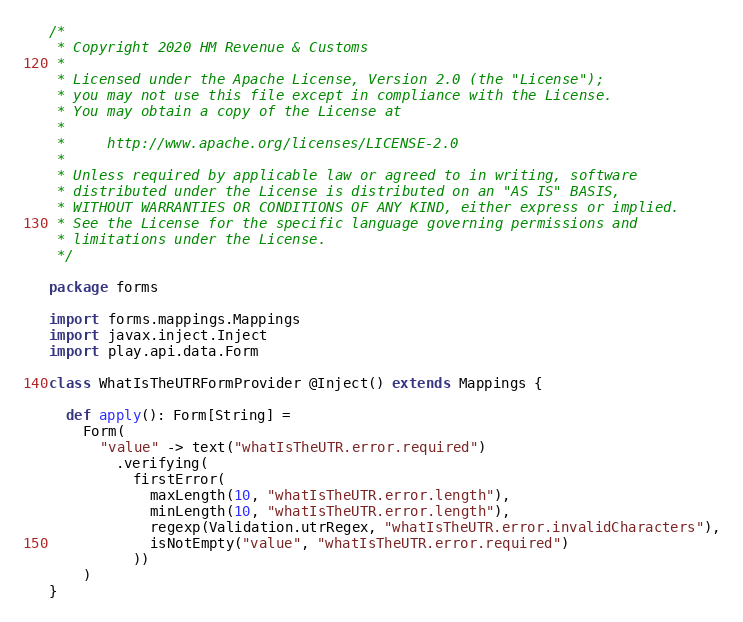<code> <loc_0><loc_0><loc_500><loc_500><_Scala_>/*
 * Copyright 2020 HM Revenue & Customs
 *
 * Licensed under the Apache License, Version 2.0 (the "License");
 * you may not use this file except in compliance with the License.
 * You may obtain a copy of the License at
 *
 *     http://www.apache.org/licenses/LICENSE-2.0
 *
 * Unless required by applicable law or agreed to in writing, software
 * distributed under the License is distributed on an "AS IS" BASIS,
 * WITHOUT WARRANTIES OR CONDITIONS OF ANY KIND, either express or implied.
 * See the License for the specific language governing permissions and
 * limitations under the License.
 */

package forms

import forms.mappings.Mappings
import javax.inject.Inject
import play.api.data.Form

class WhatIsTheUTRFormProvider @Inject() extends Mappings {

  def apply(): Form[String] =
    Form(
      "value" -> text("whatIsTheUTR.error.required")
        .verifying(
          firstError(
            maxLength(10, "whatIsTheUTR.error.length"),
            minLength(10, "whatIsTheUTR.error.length"),
            regexp(Validation.utrRegex, "whatIsTheUTR.error.invalidCharacters"),
            isNotEmpty("value", "whatIsTheUTR.error.required")
          ))
    )
}


</code> 